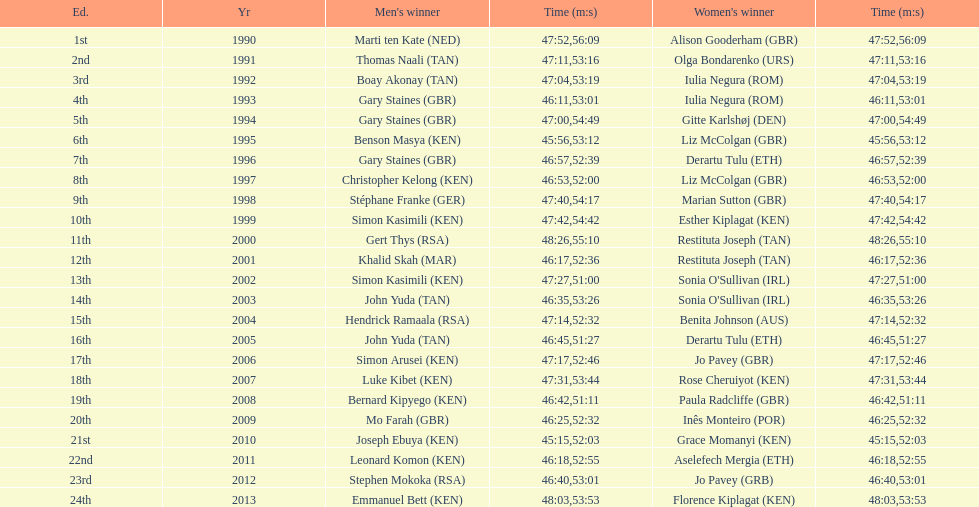Where any women faster than any men? No. Could you parse the entire table as a dict? {'header': ['Ed.', 'Yr', "Men's winner", 'Time (m:s)', "Women's winner", 'Time (m:s)'], 'rows': [['1st', '1990', 'Marti ten Kate\xa0(NED)', '47:52', 'Alison Gooderham\xa0(GBR)', '56:09'], ['2nd', '1991', 'Thomas Naali\xa0(TAN)', '47:11', 'Olga Bondarenko\xa0(URS)', '53:16'], ['3rd', '1992', 'Boay Akonay\xa0(TAN)', '47:04', 'Iulia Negura\xa0(ROM)', '53:19'], ['4th', '1993', 'Gary Staines\xa0(GBR)', '46:11', 'Iulia Negura\xa0(ROM)', '53:01'], ['5th', '1994', 'Gary Staines\xa0(GBR)', '47:00', 'Gitte Karlshøj\xa0(DEN)', '54:49'], ['6th', '1995', 'Benson Masya\xa0(KEN)', '45:56', 'Liz McColgan\xa0(GBR)', '53:12'], ['7th', '1996', 'Gary Staines\xa0(GBR)', '46:57', 'Derartu Tulu\xa0(ETH)', '52:39'], ['8th', '1997', 'Christopher Kelong\xa0(KEN)', '46:53', 'Liz McColgan\xa0(GBR)', '52:00'], ['9th', '1998', 'Stéphane Franke\xa0(GER)', '47:40', 'Marian Sutton\xa0(GBR)', '54:17'], ['10th', '1999', 'Simon Kasimili\xa0(KEN)', '47:42', 'Esther Kiplagat\xa0(KEN)', '54:42'], ['11th', '2000', 'Gert Thys\xa0(RSA)', '48:26', 'Restituta Joseph\xa0(TAN)', '55:10'], ['12th', '2001', 'Khalid Skah\xa0(MAR)', '46:17', 'Restituta Joseph\xa0(TAN)', '52:36'], ['13th', '2002', 'Simon Kasimili\xa0(KEN)', '47:27', "Sonia O'Sullivan\xa0(IRL)", '51:00'], ['14th', '2003', 'John Yuda\xa0(TAN)', '46:35', "Sonia O'Sullivan\xa0(IRL)", '53:26'], ['15th', '2004', 'Hendrick Ramaala\xa0(RSA)', '47:14', 'Benita Johnson\xa0(AUS)', '52:32'], ['16th', '2005', 'John Yuda\xa0(TAN)', '46:45', 'Derartu Tulu\xa0(ETH)', '51:27'], ['17th', '2006', 'Simon Arusei\xa0(KEN)', '47:17', 'Jo Pavey\xa0(GBR)', '52:46'], ['18th', '2007', 'Luke Kibet\xa0(KEN)', '47:31', 'Rose Cheruiyot\xa0(KEN)', '53:44'], ['19th', '2008', 'Bernard Kipyego\xa0(KEN)', '46:42', 'Paula Radcliffe\xa0(GBR)', '51:11'], ['20th', '2009', 'Mo Farah\xa0(GBR)', '46:25', 'Inês Monteiro\xa0(POR)', '52:32'], ['21st', '2010', 'Joseph Ebuya\xa0(KEN)', '45:15', 'Grace Momanyi\xa0(KEN)', '52:03'], ['22nd', '2011', 'Leonard Komon\xa0(KEN)', '46:18', 'Aselefech Mergia\xa0(ETH)', '52:55'], ['23rd', '2012', 'Stephen Mokoka\xa0(RSA)', '46:40', 'Jo Pavey\xa0(GRB)', '53:01'], ['24th', '2013', 'Emmanuel Bett\xa0(KEN)', '48:03', 'Florence Kiplagat\xa0(KEN)', '53:53']]} 